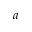<formula> <loc_0><loc_0><loc_500><loc_500>a</formula> 